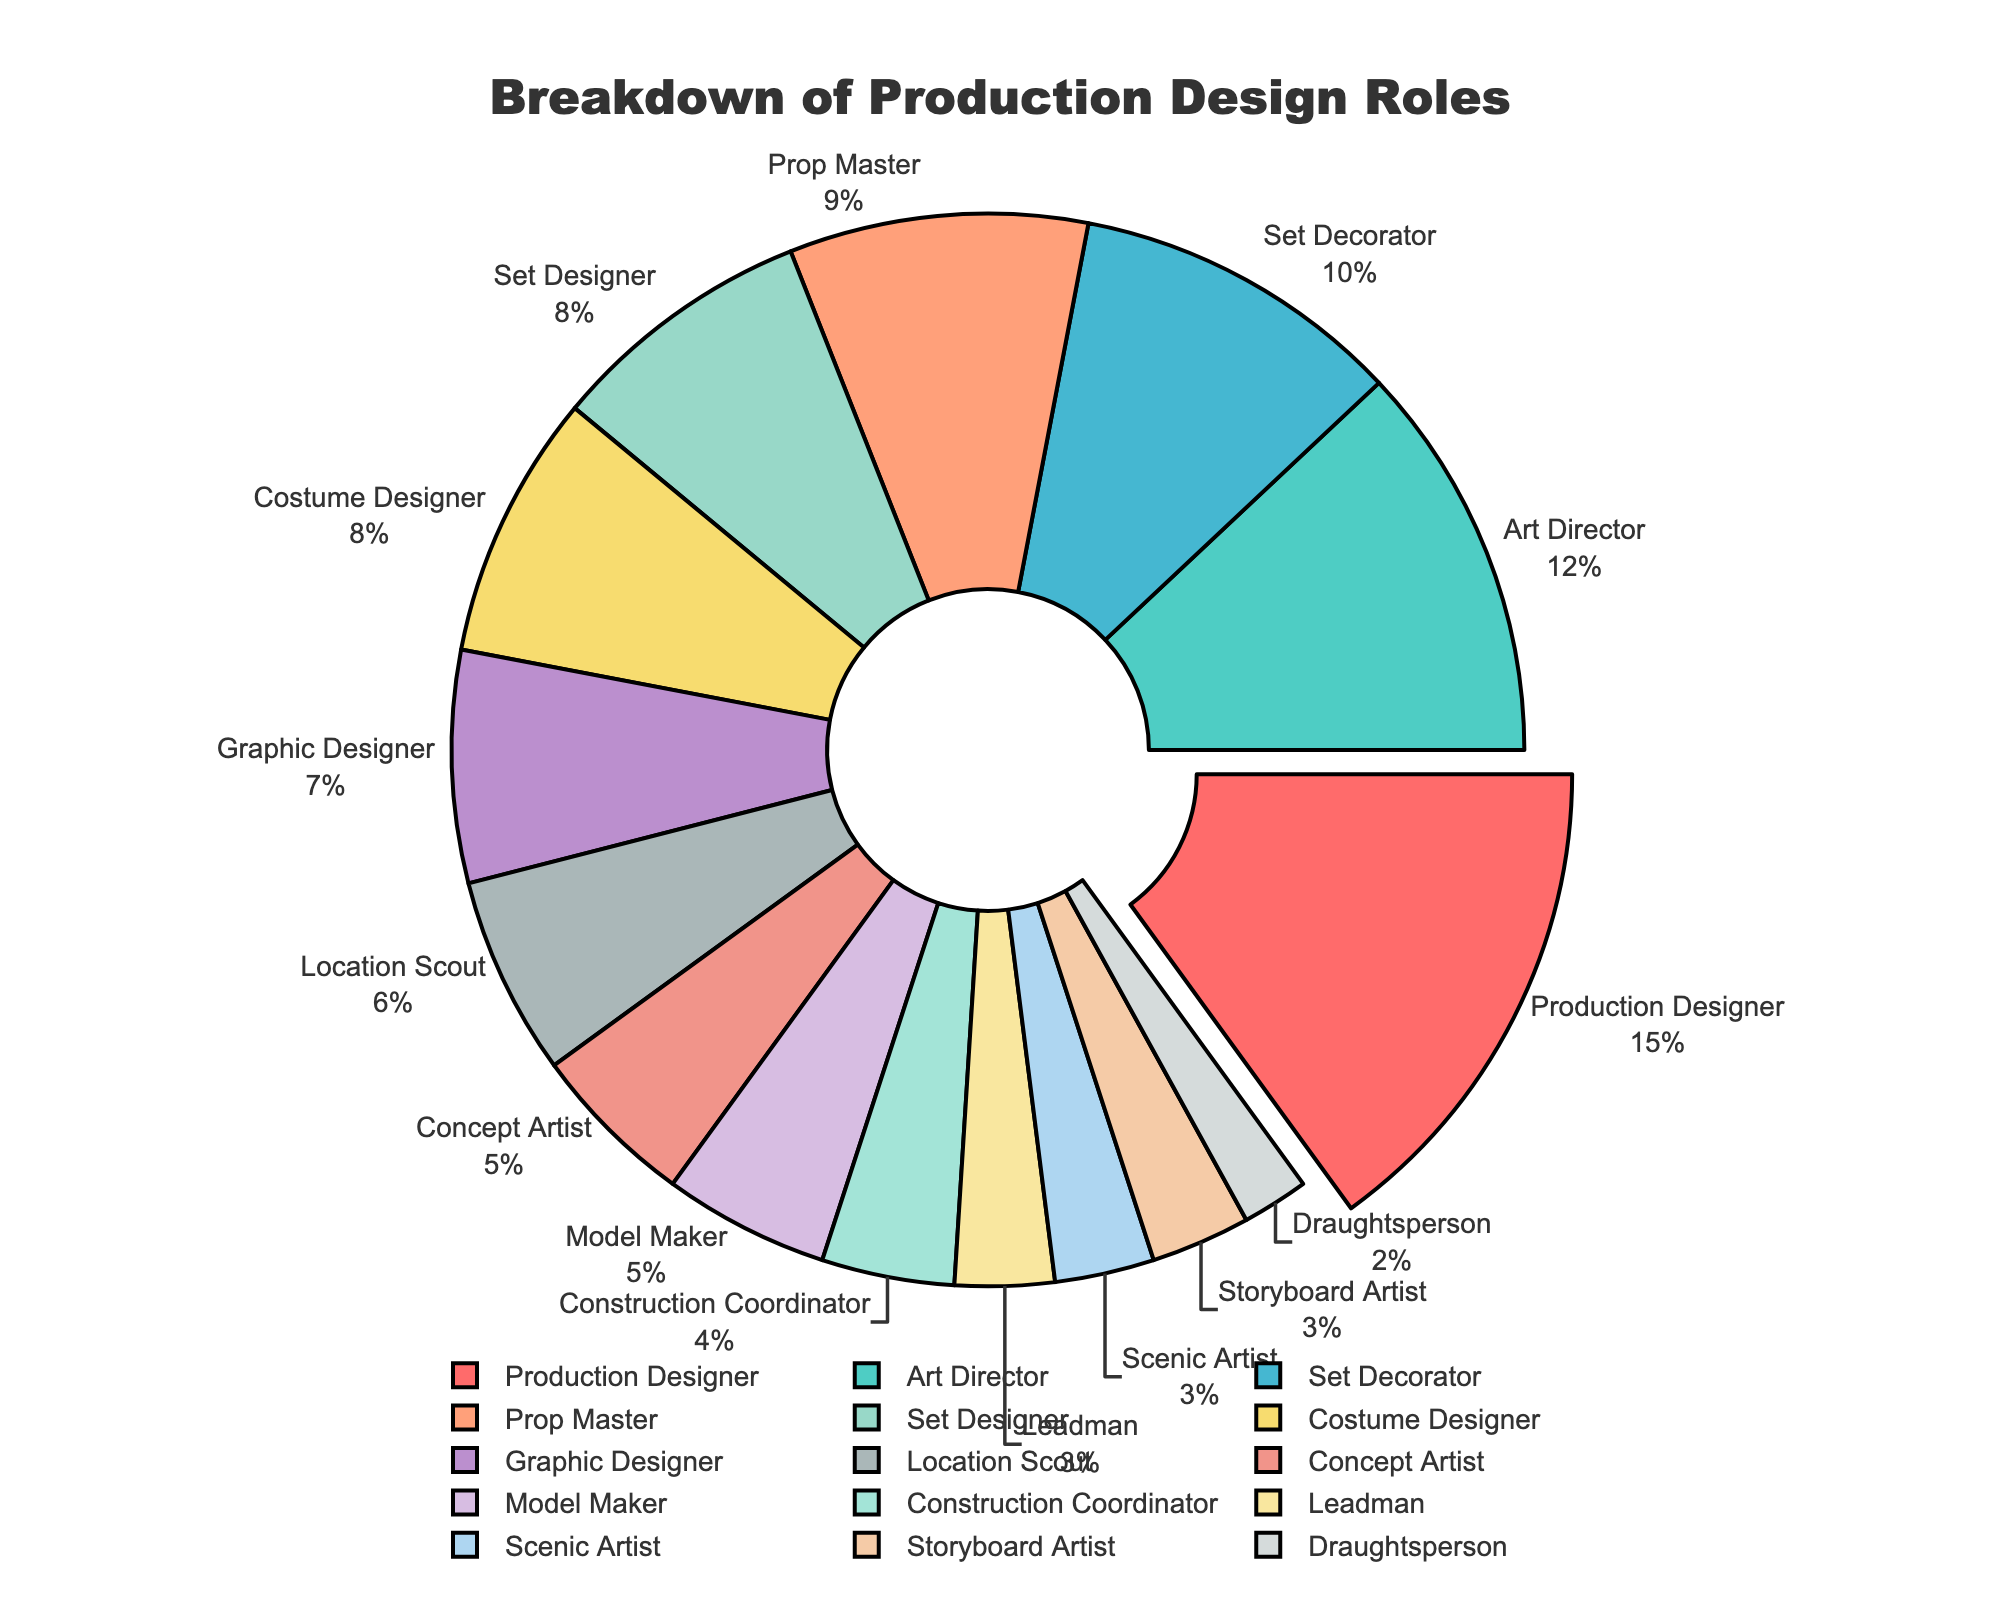What's the role with the highest percentage? By looking at the sizes of the segments in the pie chart, the largest segment corresponds to the Production Designer role. This role is also highlighted by being slightly pulled out from the rest of the pie.
Answer: Production Designer Which roles have a lower percentage than the Costume Designer? By observing the percentage labels outside the segments, the roles with percentages lower than 8% (Costume Designer) are Graphic Designer, Location Scout, Concept Artist, Model Maker, Construction Coordinator, Leadman, Scenic Artist, Storyboard Artist, and Draughtsperson.
Answer: Graphic Designer, Location Scout, Concept Artist, Model Maker, Construction Coordinator, Leadman, Scenic Artist, Storyboard Artist, Draughtsperson What is the combined percentage of the Art Director and Set Decorator roles? Adding the percentage values from the pie chart for the Art Director (12%) and Set Decorator (10%) gives us 12% + 10% = 22%.
Answer: 22% Which role has the same percentage as the Set Designer? By comparing the percentages displayed, the Set Designer and the Costume Designer both have 8%.
Answer: Costume Designer What is the total percentage of the roles occupying less than 5% each? Adding the percentage values from the pie chart: Model Maker (5%), Construction Coordinator (4%), Leadman (3%), Scenic Artist (3%), Storyboard Artist (3%), Draughtsperson (2%). The total is 5% + 4% + 3% + 3% + 3% + 2% = 20%.
Answer: 20% Which role is the smallest segment in the pie chart? By comparing the sizes of the segments, the Draughtsperson role is the smallest as it occupies 2% of the chart.
Answer: Draughtsperson How do the combined percentages of the Graphic Designer and Location Scout compare to the Production Designer? Adding the Graphic Designer (7%) and Location Scout (6%) gives 7% + 6% = 13%, which is less than the Production Designer’s 15%.
Answer: less than What color is the segment for the Concept Artist role? By visually identifying the segment labeled as Concept Artist, it's easy to see that it is the segment colored in a hue which appears to be purplish.
Answer: purple 